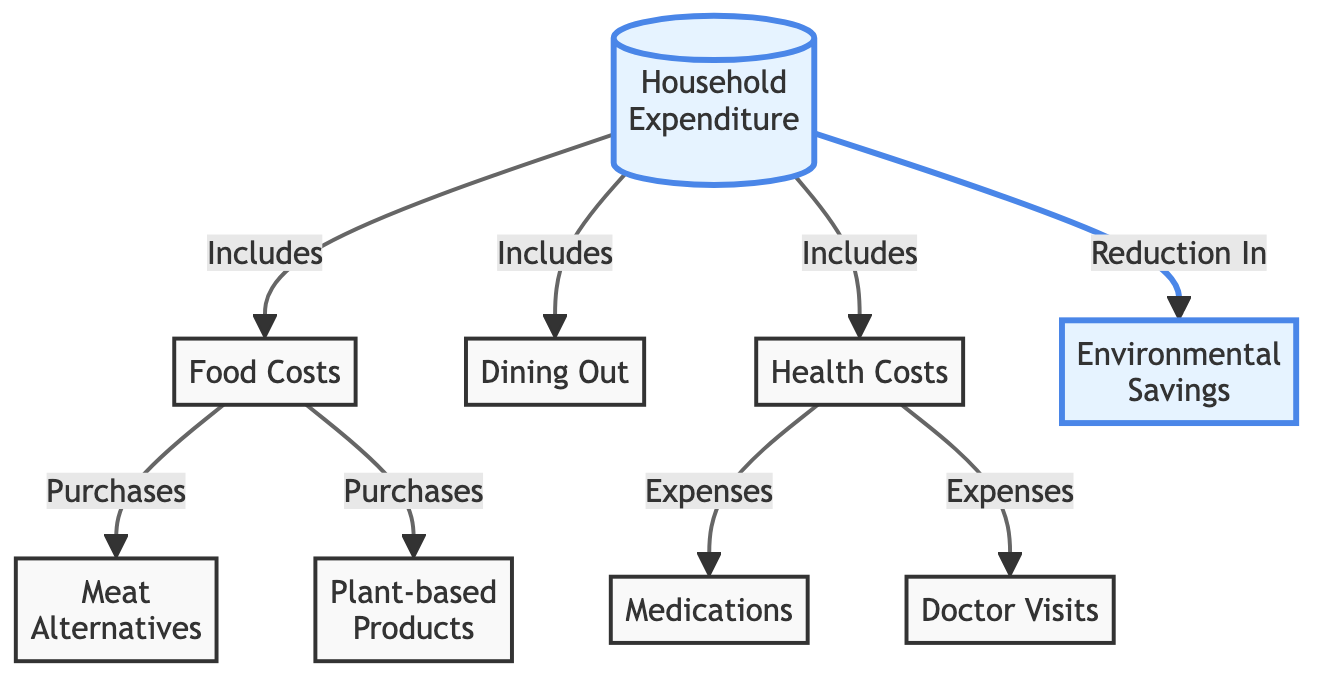What is included in household expenditure? The diagram shows that household expenditure includes food costs, dining out, and health costs. To answer this, we need to look at the nodes directly connected to "Household Expenditure" and note down what they are.
Answer: food costs, dining out, health costs How many types of expenses are shown under health costs? According to the diagram, health costs have two expenses connected to it: medications and doctor visits. Counting the nodes directly connected to "Health Costs" gives us the answer.
Answer: 2 What is a source of savings indicated in the diagram? The diagram indicates that one type of saving related to household expenditure is the environmental savings, which is explicitly connected to household expenditure as a reduction. This node helps identify savings.
Answer: Environmental Savings Which category has purchases listed in food costs? The diagram shows that "Food Costs" includes purchases for "Meat Alternatives" and "Plant-based Products". By examining the edges leading from "Food Costs," we find these two categories that specify purchases.
Answer: Meat Alternatives, Plant-based Products How do health costs relate to household expenditure? The diagram demonstrates that health costs are part of household expenditure, as indicated by the direct connection from "Household Expenditure" to "Health Costs." Thus, it involves assessing how health costs impact overall spending.
Answer: Includes What two factors are expenses under health costs? By looking closely at the "Health Costs" node, we note it connects to two expenses: "Medications" and "Doctor Visits." Investigating what nodes branch out from "Health Costs" gives the required answer.
Answer: Medications, Doctor Visits What does the reduction in household expenditure lead to? The diagram shows that there is a reduction in household expenditure that leads to environmental savings. This entails understanding the causation indicated in the diagram where one aspect leads to another.
Answer: Environmental Savings What types of products are emphasized in food costs? The diagram denotes that food costs emphasize "Meat Alternatives" and "Plant-based Products." Identifying these products requires looking at the branches stemming from the "Food Costs" node.
Answer: Meat Alternatives, Plant-based Products 